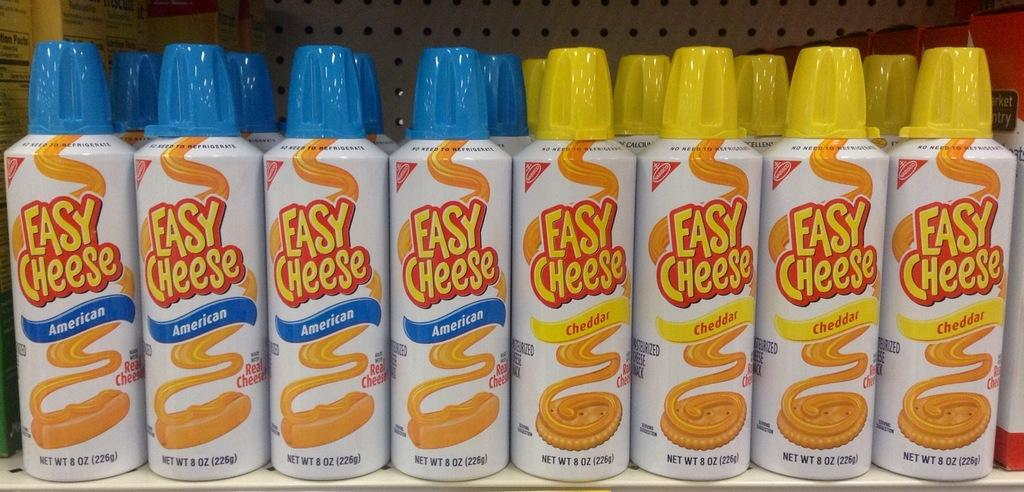<image>
Relay a brief, clear account of the picture shown. Four cans of American easy cheese to the left and four Cheddar easy cheese to the right, on a shelf with more behind each bottle 